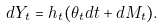<formula> <loc_0><loc_0><loc_500><loc_500>d Y _ { t } = h _ { t } ( \theta _ { t } d t + d M _ { t } ) .</formula> 